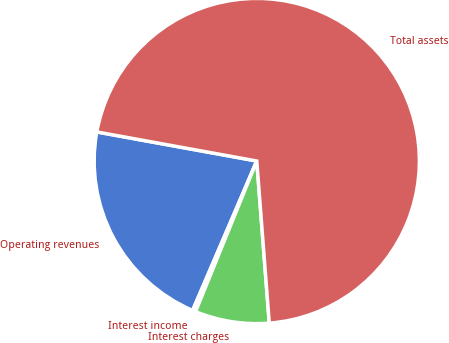<chart> <loc_0><loc_0><loc_500><loc_500><pie_chart><fcel>Operating revenues<fcel>Interest income<fcel>Interest charges<fcel>Total assets<nl><fcel>21.41%<fcel>0.31%<fcel>7.37%<fcel>70.92%<nl></chart> 